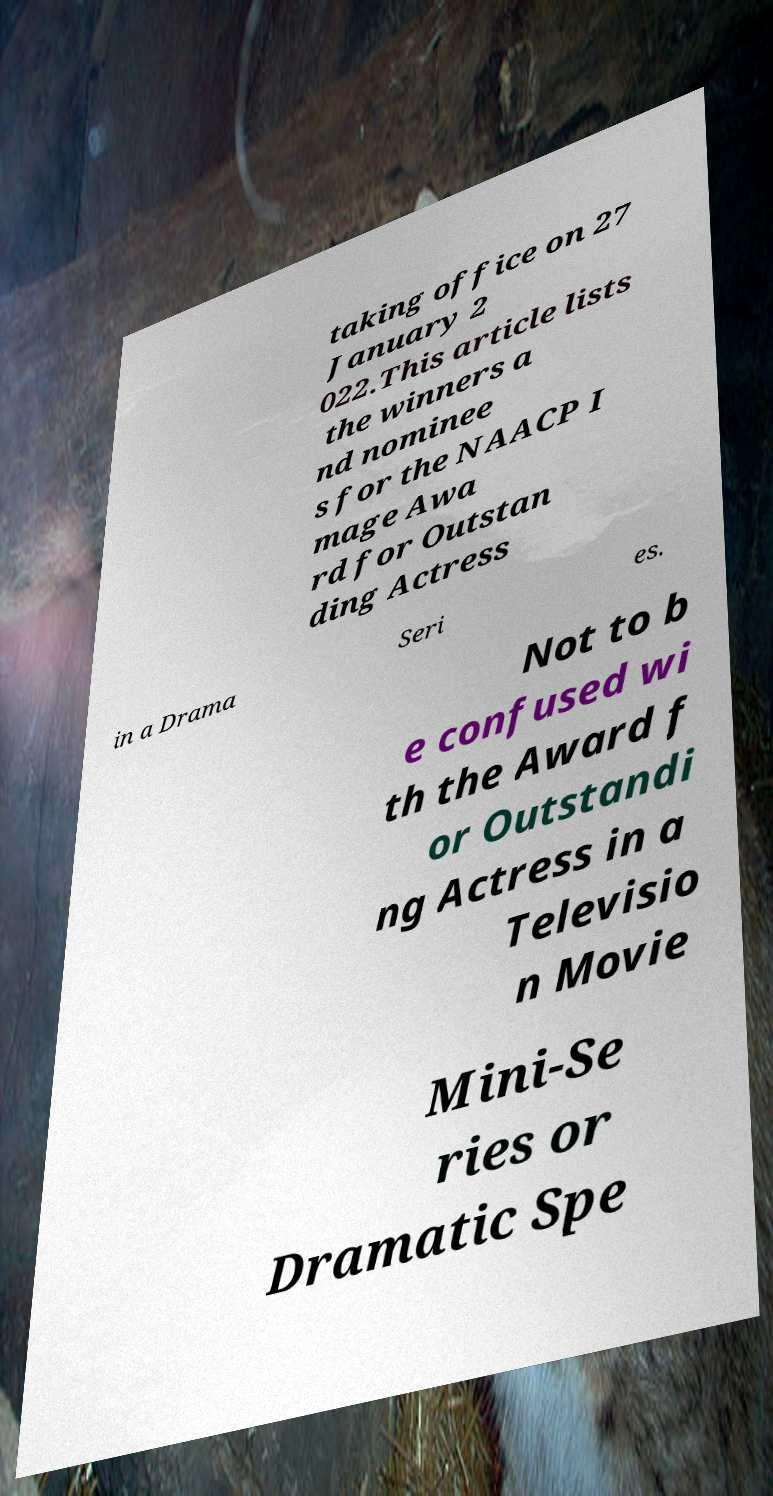Can you read and provide the text displayed in the image?This photo seems to have some interesting text. Can you extract and type it out for me? taking office on 27 January 2 022.This article lists the winners a nd nominee s for the NAACP I mage Awa rd for Outstan ding Actress in a Drama Seri es. Not to b e confused wi th the Award f or Outstandi ng Actress in a Televisio n Movie Mini-Se ries or Dramatic Spe 